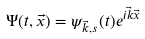<formula> <loc_0><loc_0><loc_500><loc_500>\Psi ( t , \vec { x } ) = \psi _ { \vec { k } , s } ( t ) e ^ { i \vec { k } \vec { x } }</formula> 